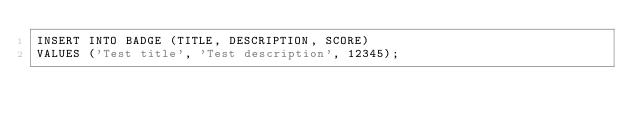Convert code to text. <code><loc_0><loc_0><loc_500><loc_500><_SQL_>INSERT INTO BADGE (TITLE, DESCRIPTION, SCORE)
VALUES ('Test title', 'Test description', 12345);</code> 